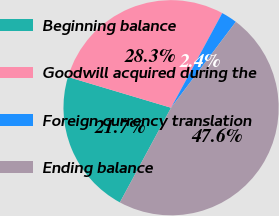Convert chart to OTSL. <chart><loc_0><loc_0><loc_500><loc_500><pie_chart><fcel>Beginning balance<fcel>Goodwill acquired during the<fcel>Foreign currency translation<fcel>Ending balance<nl><fcel>21.73%<fcel>28.27%<fcel>2.39%<fcel>47.61%<nl></chart> 